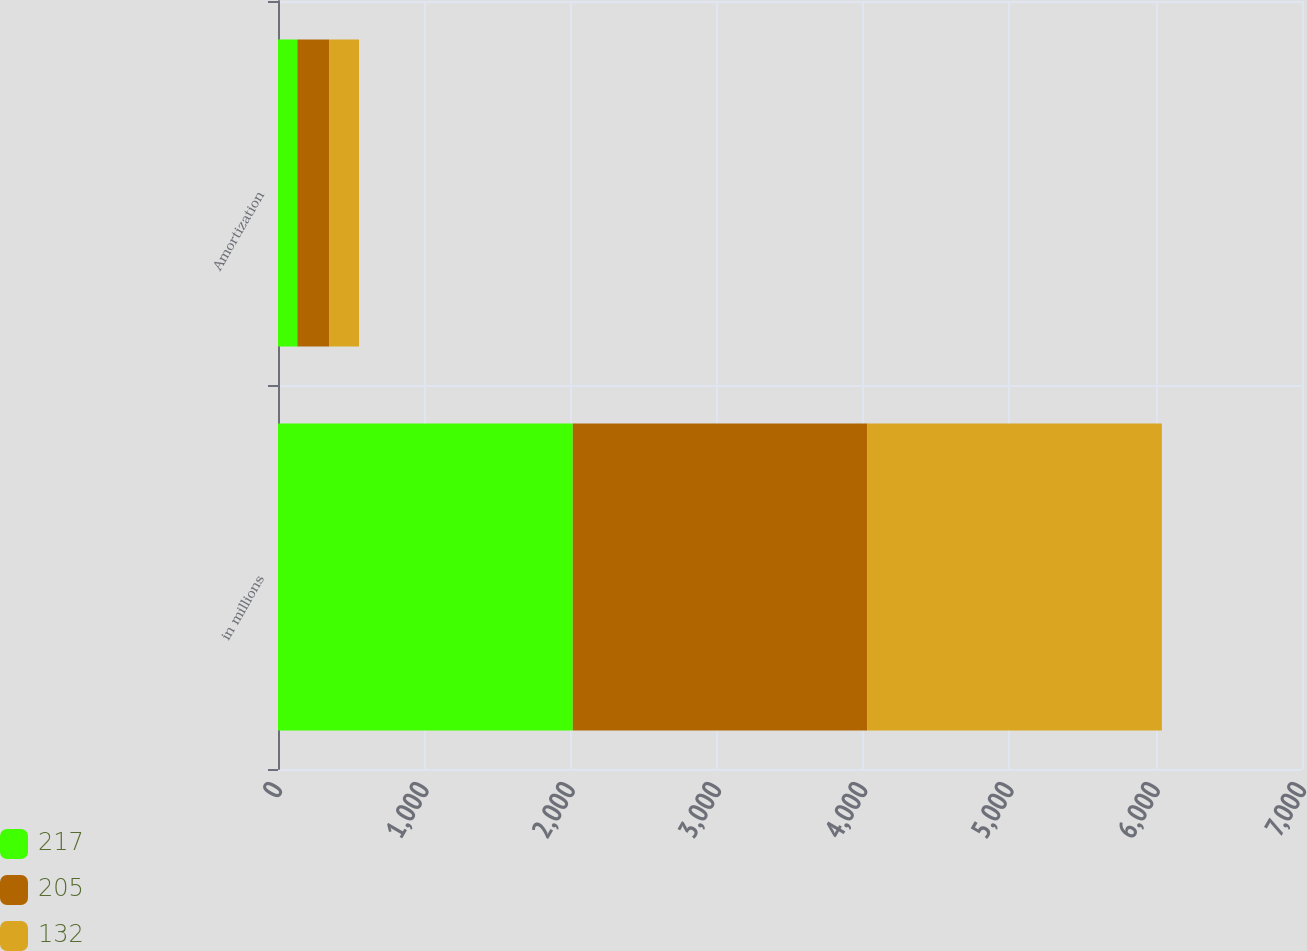<chart> <loc_0><loc_0><loc_500><loc_500><stacked_bar_chart><ecel><fcel>in millions<fcel>Amortization<nl><fcel>217<fcel>2015<fcel>132<nl><fcel>205<fcel>2014<fcel>217<nl><fcel>132<fcel>2013<fcel>205<nl></chart> 